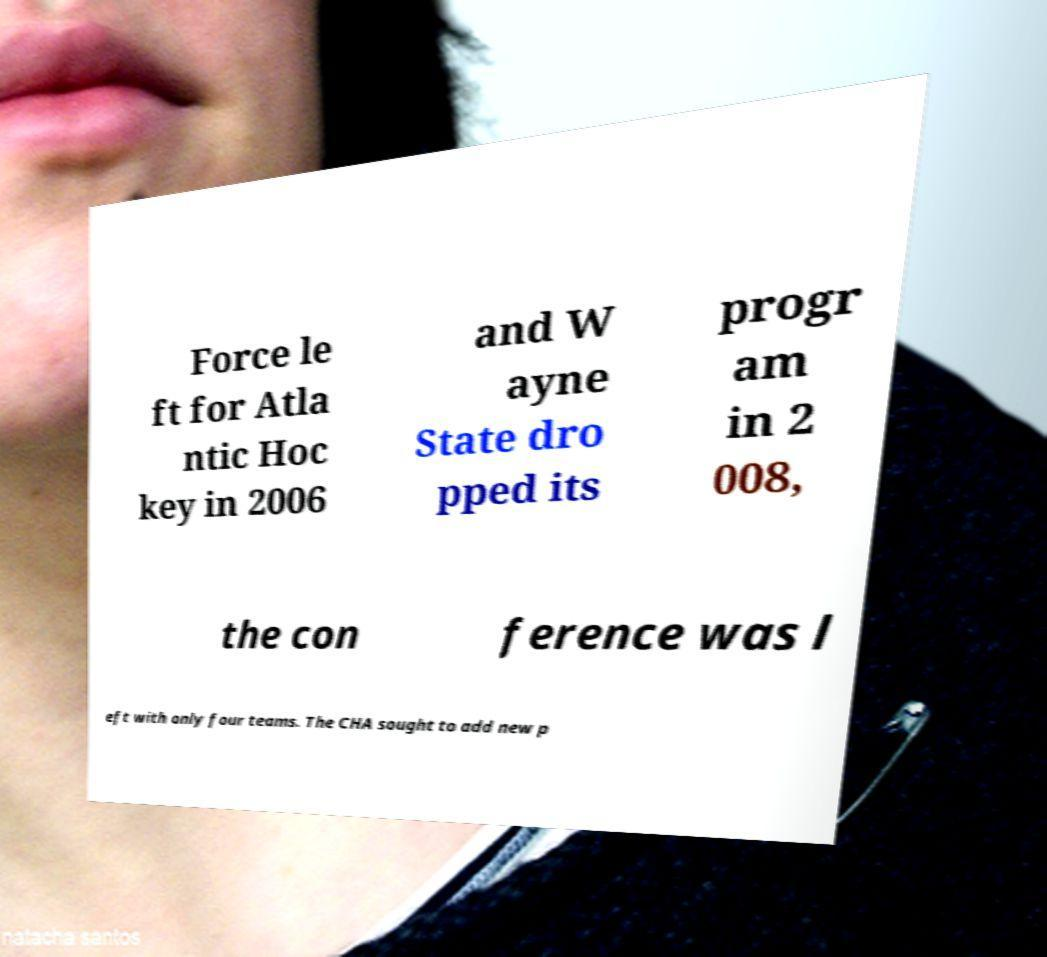Can you read and provide the text displayed in the image?This photo seems to have some interesting text. Can you extract and type it out for me? Force le ft for Atla ntic Hoc key in 2006 and W ayne State dro pped its progr am in 2 008, the con ference was l eft with only four teams. The CHA sought to add new p 